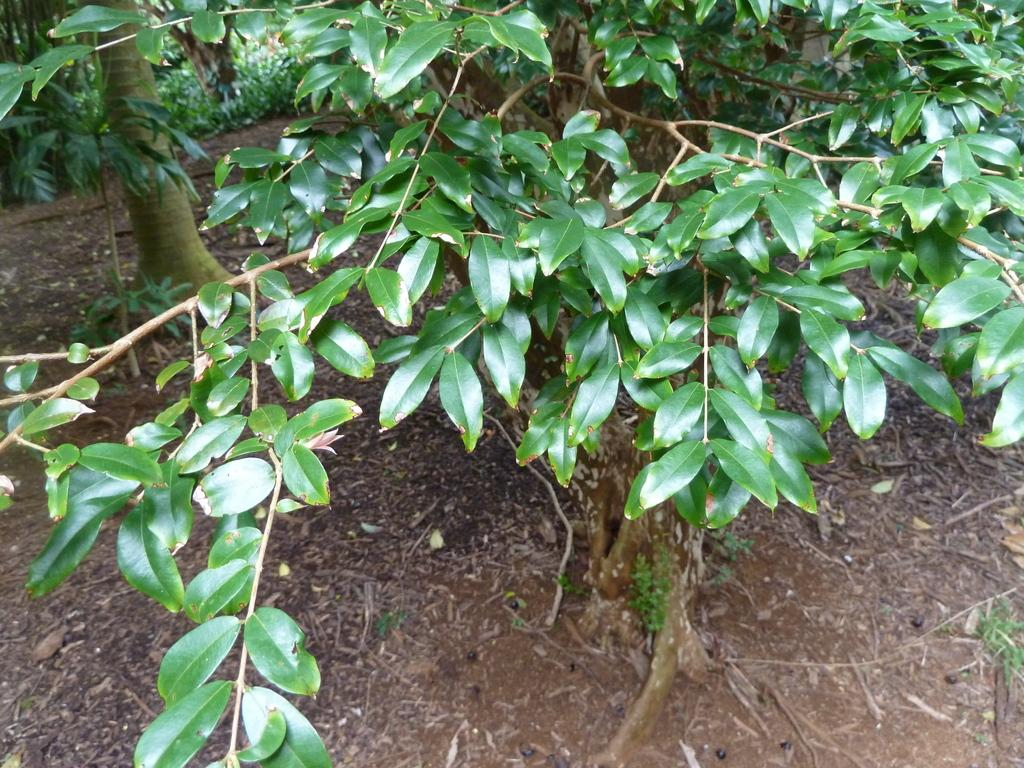What type of vegetation can be seen in the image? There are trees in the image. Can you see the grandfather's lip in the image? There is no person or lip present in the image; it only features trees. 